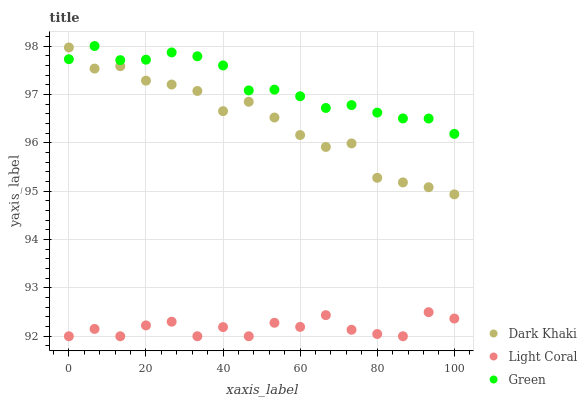Does Light Coral have the minimum area under the curve?
Answer yes or no. Yes. Does Green have the maximum area under the curve?
Answer yes or no. Yes. Does Green have the minimum area under the curve?
Answer yes or no. No. Does Light Coral have the maximum area under the curve?
Answer yes or no. No. Is Green the smoothest?
Answer yes or no. Yes. Is Light Coral the roughest?
Answer yes or no. Yes. Is Light Coral the smoothest?
Answer yes or no. No. Is Green the roughest?
Answer yes or no. No. Does Light Coral have the lowest value?
Answer yes or no. Yes. Does Green have the lowest value?
Answer yes or no. No. Does Green have the highest value?
Answer yes or no. Yes. Does Light Coral have the highest value?
Answer yes or no. No. Is Light Coral less than Green?
Answer yes or no. Yes. Is Dark Khaki greater than Light Coral?
Answer yes or no. Yes. Does Green intersect Dark Khaki?
Answer yes or no. Yes. Is Green less than Dark Khaki?
Answer yes or no. No. Is Green greater than Dark Khaki?
Answer yes or no. No. Does Light Coral intersect Green?
Answer yes or no. No. 